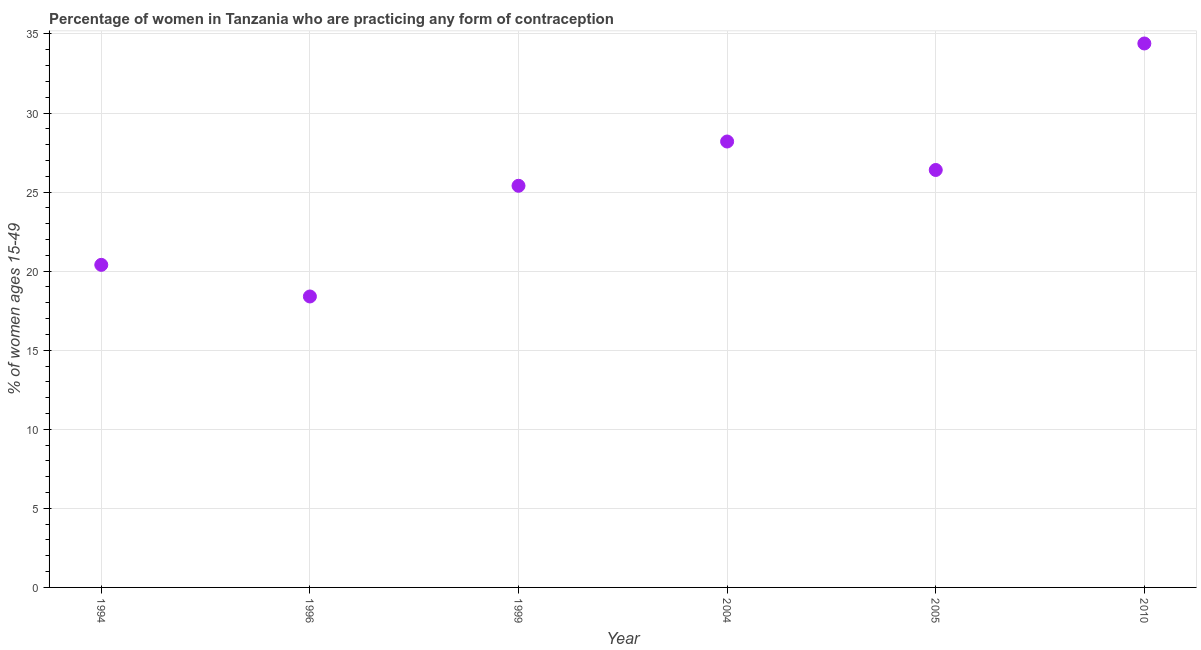What is the contraceptive prevalence in 2005?
Give a very brief answer. 26.4. Across all years, what is the maximum contraceptive prevalence?
Your answer should be very brief. 34.4. Across all years, what is the minimum contraceptive prevalence?
Your response must be concise. 18.4. In which year was the contraceptive prevalence minimum?
Make the answer very short. 1996. What is the sum of the contraceptive prevalence?
Make the answer very short. 153.2. What is the difference between the contraceptive prevalence in 1996 and 1999?
Provide a succinct answer. -7. What is the average contraceptive prevalence per year?
Your answer should be very brief. 25.53. What is the median contraceptive prevalence?
Make the answer very short. 25.9. In how many years, is the contraceptive prevalence greater than 34 %?
Give a very brief answer. 1. Do a majority of the years between 2010 and 2005 (inclusive) have contraceptive prevalence greater than 17 %?
Your answer should be compact. No. What is the ratio of the contraceptive prevalence in 1996 to that in 2010?
Your answer should be very brief. 0.53. Is the difference between the contraceptive prevalence in 2004 and 2010 greater than the difference between any two years?
Your answer should be compact. No. What is the difference between the highest and the second highest contraceptive prevalence?
Provide a succinct answer. 6.2. How many dotlines are there?
Provide a succinct answer. 1. How many years are there in the graph?
Keep it short and to the point. 6. Are the values on the major ticks of Y-axis written in scientific E-notation?
Provide a short and direct response. No. Does the graph contain grids?
Offer a terse response. Yes. What is the title of the graph?
Ensure brevity in your answer.  Percentage of women in Tanzania who are practicing any form of contraception. What is the label or title of the X-axis?
Ensure brevity in your answer.  Year. What is the label or title of the Y-axis?
Your answer should be compact. % of women ages 15-49. What is the % of women ages 15-49 in 1994?
Your response must be concise. 20.4. What is the % of women ages 15-49 in 1999?
Your response must be concise. 25.4. What is the % of women ages 15-49 in 2004?
Your response must be concise. 28.2. What is the % of women ages 15-49 in 2005?
Your answer should be very brief. 26.4. What is the % of women ages 15-49 in 2010?
Offer a very short reply. 34.4. What is the difference between the % of women ages 15-49 in 1994 and 2005?
Offer a very short reply. -6. What is the difference between the % of women ages 15-49 in 1999 and 2004?
Offer a very short reply. -2.8. What is the difference between the % of women ages 15-49 in 1999 and 2005?
Your answer should be compact. -1. What is the difference between the % of women ages 15-49 in 1999 and 2010?
Your answer should be compact. -9. What is the difference between the % of women ages 15-49 in 2005 and 2010?
Provide a short and direct response. -8. What is the ratio of the % of women ages 15-49 in 1994 to that in 1996?
Provide a succinct answer. 1.11. What is the ratio of the % of women ages 15-49 in 1994 to that in 1999?
Offer a very short reply. 0.8. What is the ratio of the % of women ages 15-49 in 1994 to that in 2004?
Make the answer very short. 0.72. What is the ratio of the % of women ages 15-49 in 1994 to that in 2005?
Your answer should be very brief. 0.77. What is the ratio of the % of women ages 15-49 in 1994 to that in 2010?
Provide a short and direct response. 0.59. What is the ratio of the % of women ages 15-49 in 1996 to that in 1999?
Offer a terse response. 0.72. What is the ratio of the % of women ages 15-49 in 1996 to that in 2004?
Provide a succinct answer. 0.65. What is the ratio of the % of women ages 15-49 in 1996 to that in 2005?
Your response must be concise. 0.7. What is the ratio of the % of women ages 15-49 in 1996 to that in 2010?
Offer a terse response. 0.54. What is the ratio of the % of women ages 15-49 in 1999 to that in 2004?
Keep it short and to the point. 0.9. What is the ratio of the % of women ages 15-49 in 1999 to that in 2005?
Your response must be concise. 0.96. What is the ratio of the % of women ages 15-49 in 1999 to that in 2010?
Offer a terse response. 0.74. What is the ratio of the % of women ages 15-49 in 2004 to that in 2005?
Give a very brief answer. 1.07. What is the ratio of the % of women ages 15-49 in 2004 to that in 2010?
Your answer should be very brief. 0.82. What is the ratio of the % of women ages 15-49 in 2005 to that in 2010?
Make the answer very short. 0.77. 